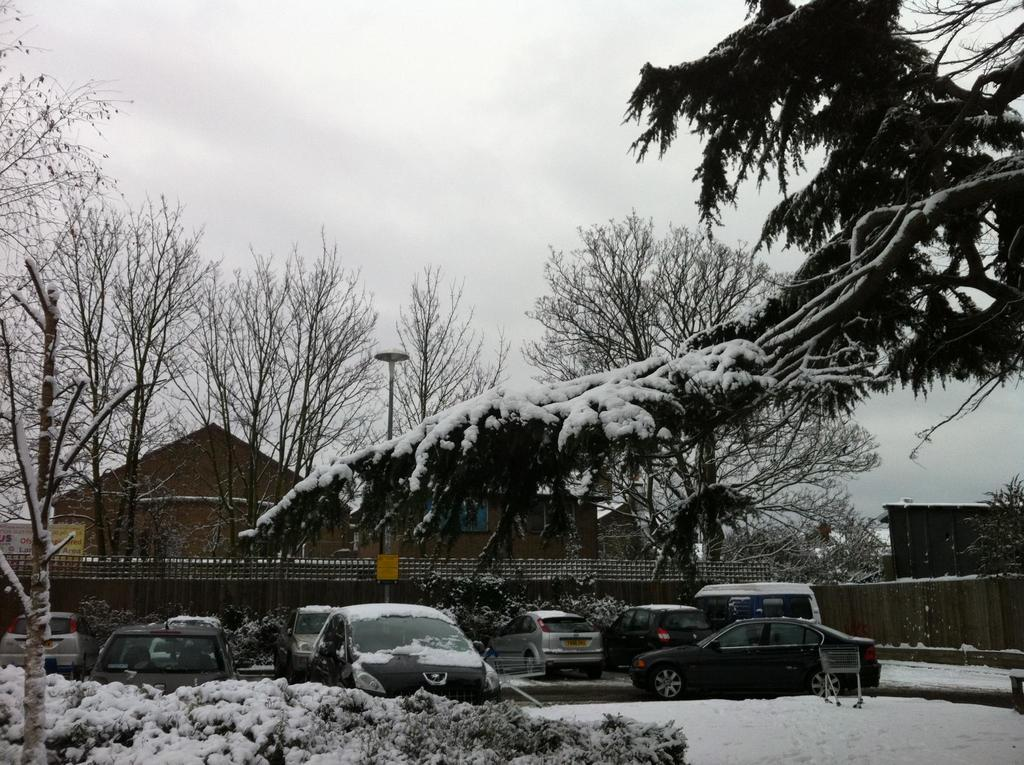What type of vegetation can be seen in the image? There are shrubs and trees in the image. What type of vehicles are present in the image? There are cars in the image. What is the condition of the road in the image? The road is covered with snow in the image. What type of house can be seen in the background? There is a wooden house in the background. What other structures can be seen in the background of the image? There is a light pole and a fence in the background. How would you describe the sky in the image? The sky is cloudy in the background. Who is the creator of the arch in the image? There is no arch present in the image. What is the fifth element in the image? The facts provided do not mention a fifth element, and there are only eight elements described. 